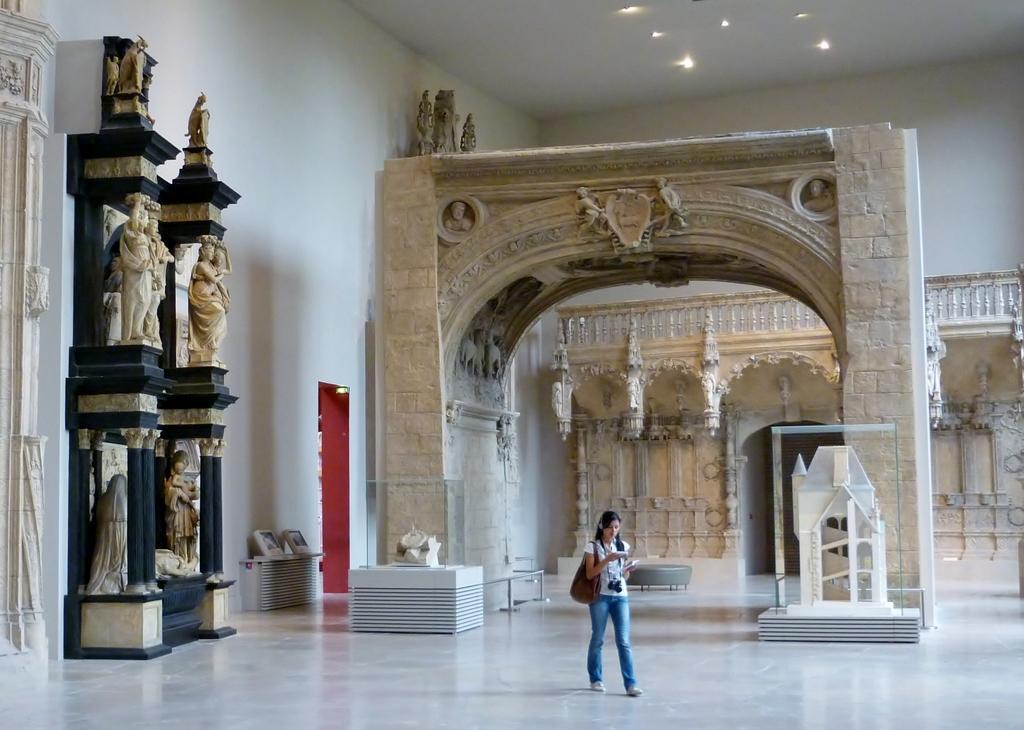Describe this image in one or two sentences. In this image I can see the arch, statues, lights, wall and few objects on the floor. I can see few sets of the buildings and one person is holding something and walking. 